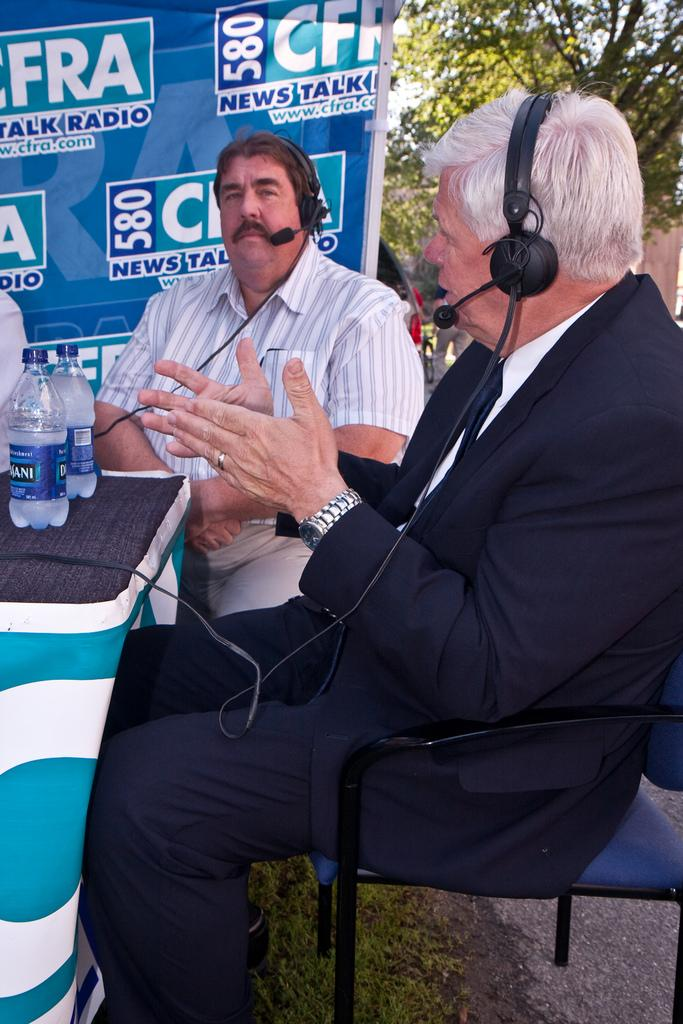How many people are sitting in the image? There are two persons sitting on chairs in the image. What is present between the two people? There is a table in the image. What can be seen on the table? There are bottles on the table. What is hanging or displayed in the image? There is a banner in the image. What type of natural element is visible in the image? There is a tree in the image. What type of flesh can be seen hanging from the tree in the image? There is no flesh hanging from the tree in the image; it is a tree with leaves or branches. 